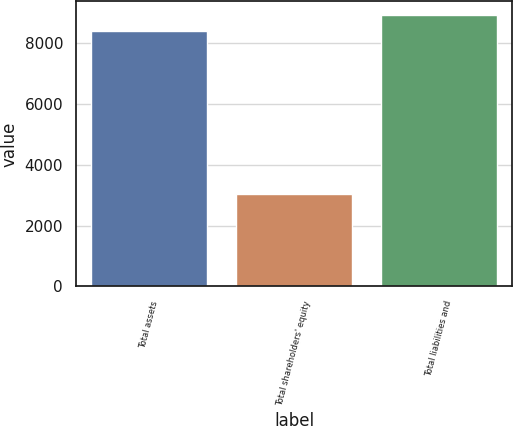<chart> <loc_0><loc_0><loc_500><loc_500><bar_chart><fcel>Total assets<fcel>Total shareholders' equity<fcel>Total liabilities and<nl><fcel>8378<fcel>3026<fcel>8913.2<nl></chart> 